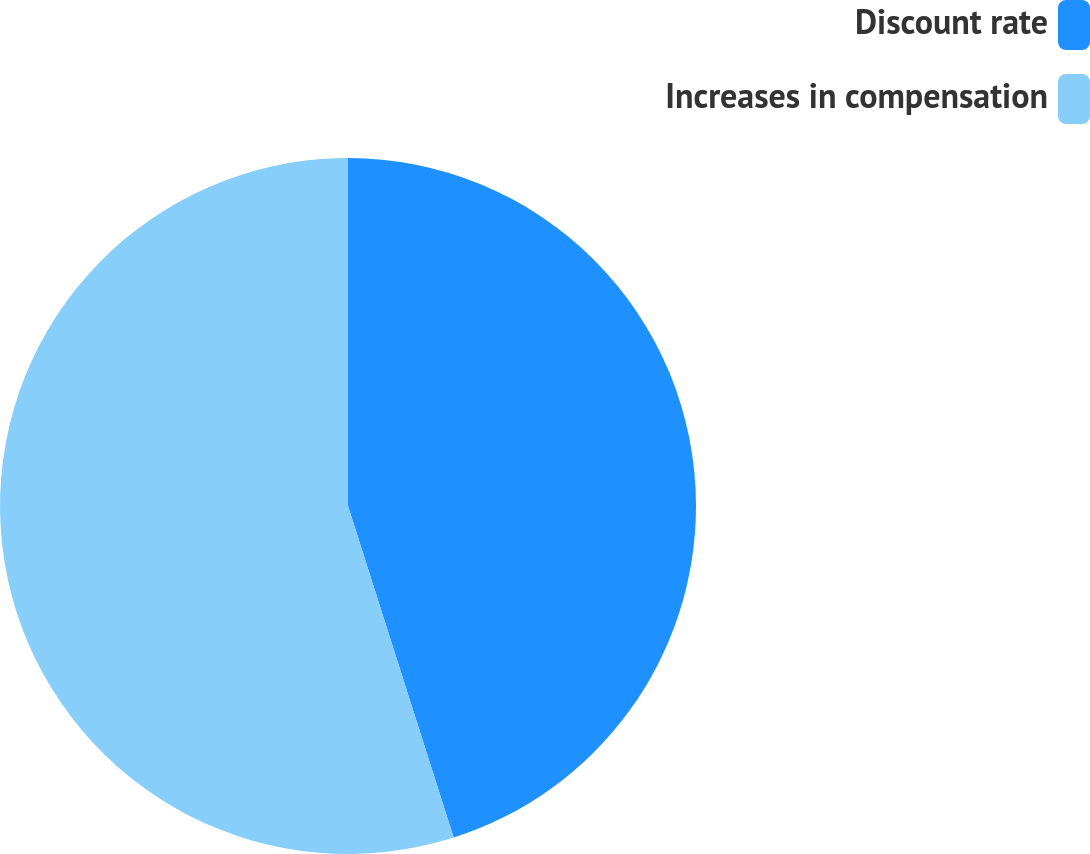Convert chart. <chart><loc_0><loc_0><loc_500><loc_500><pie_chart><fcel>Discount rate<fcel>Increases in compensation<nl><fcel>45.09%<fcel>54.91%<nl></chart> 